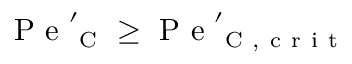<formula> <loc_0><loc_0><loc_500><loc_500>P e _ { C } ^ { \prime } \geq P e _ { C , c r i t } ^ { \prime }</formula> 